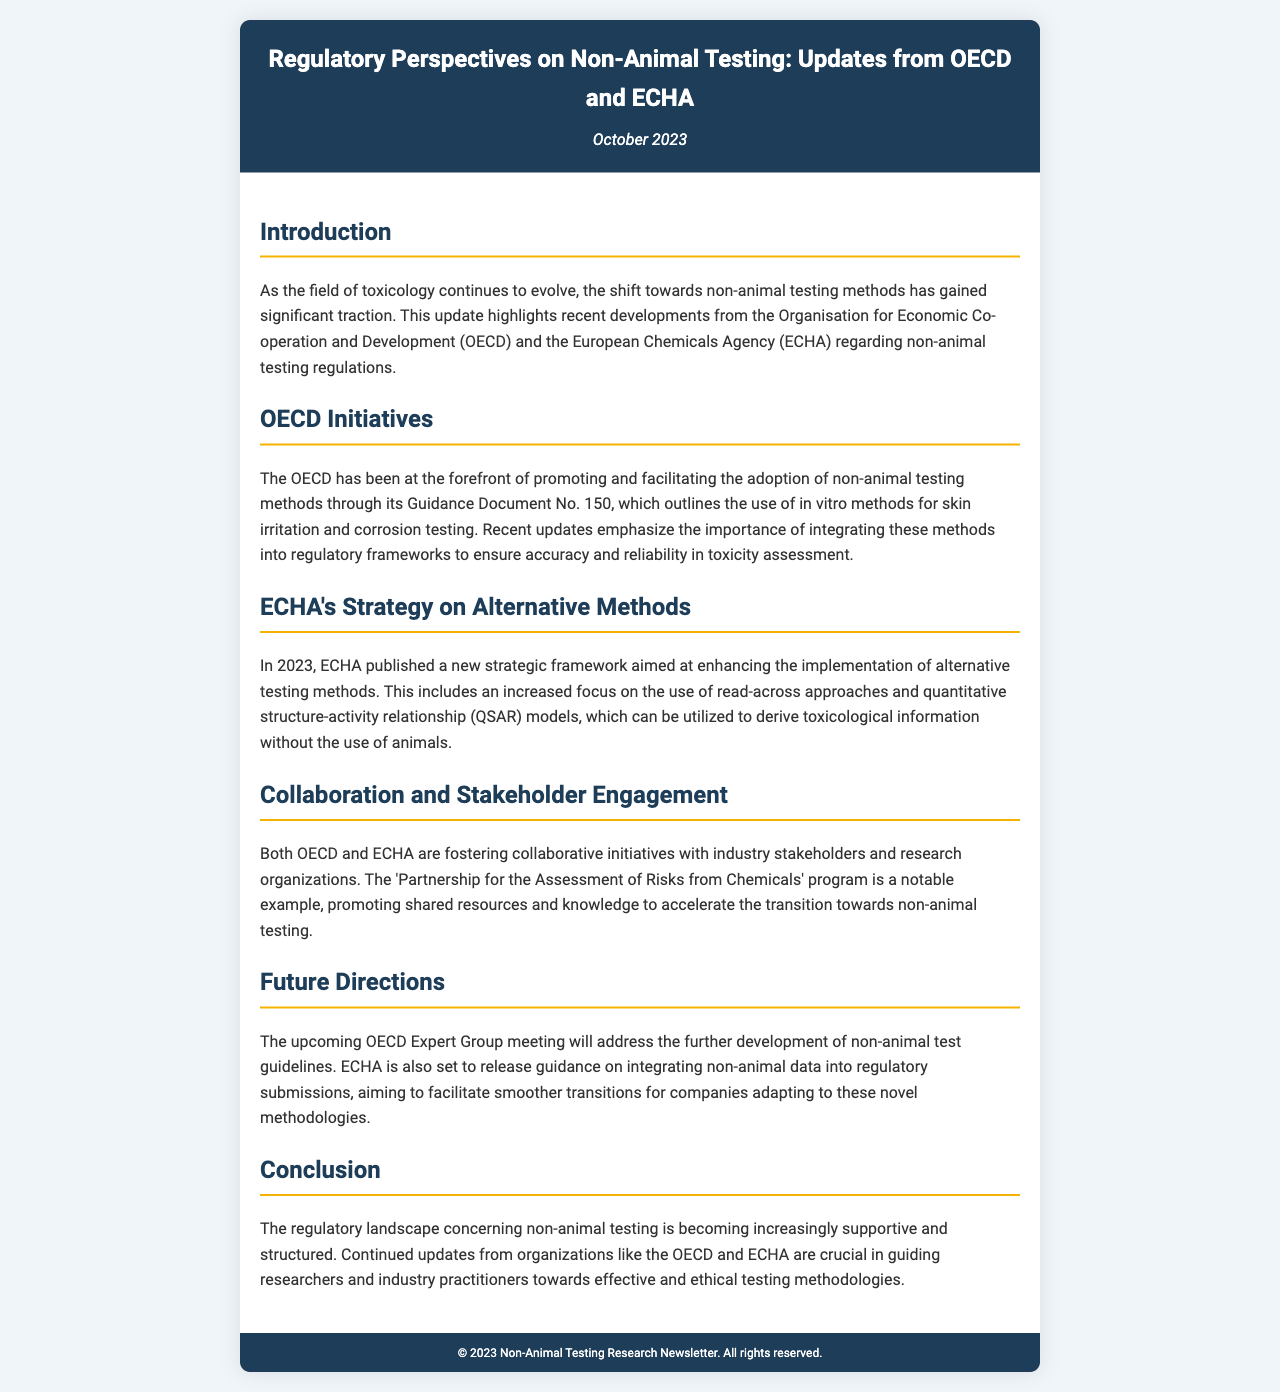what organization published Guidance Document No. 150? The document states that the OECD published Guidance Document No. 150, which outlines non-animal testing methods.
Answer: OECD what is a key focus of ECHA's new strategic framework in 2023? The strategic framework emphasizes enhancing the implementation of alternative testing methods and includes a focus on read-across approaches and QSAR models.
Answer: Alternative testing methods what will the OECD Expert Group meeting discuss? The upcoming OECD Expert Group meeting will address the further development of non-animal test guidelines.
Answer: Non-animal test guidelines which program promotes shared resources between stakeholders? The 'Partnership for the Assessment of Risks from Chemicals' program is mentioned as a collaborative initiative promoting shared resources among stakeholders.
Answer: Partnership for the Assessment of Risks from Chemicals what is the main purpose of this newsletter? The newsletter aims to provide updates on regulatory perspectives regarding non-animal testing from the OECD and ECHA.
Answer: Updates on regulatory perspectives when was this newsletter published? The date mentioned in the newsletter indicates it was published in October 2023.
Answer: October 2023 what is the concluding sentiment expressed about the regulatory landscape for non-animal testing? The conclusion states that the regulatory landscape is becoming increasingly supportive and structured regarding non-animal testing methods.
Answer: Supportive and structured 